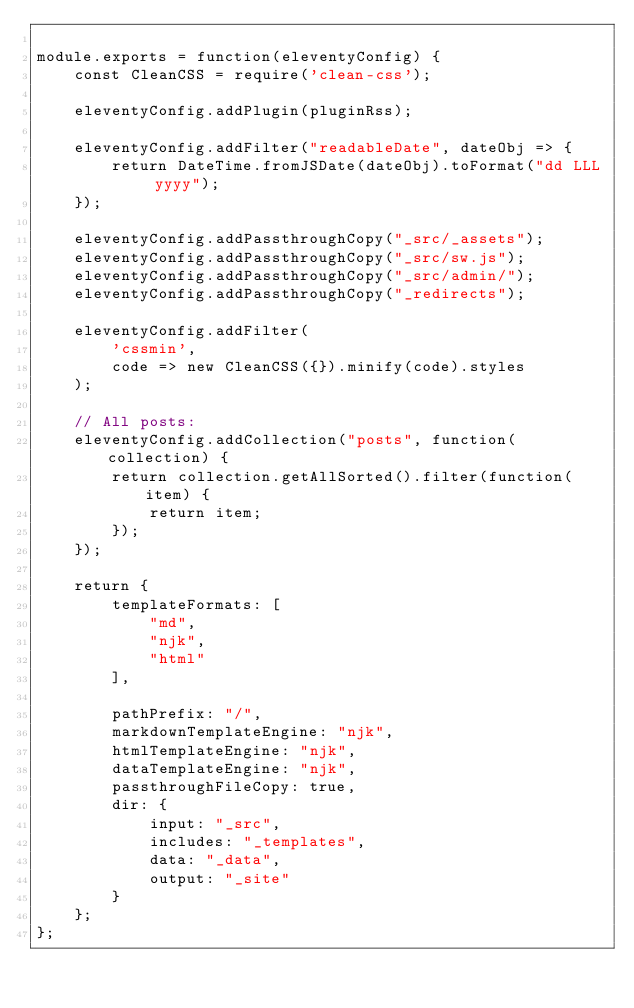Convert code to text. <code><loc_0><loc_0><loc_500><loc_500><_JavaScript_>
module.exports = function(eleventyConfig) {
	const CleanCSS = require('clean-css');

	eleventyConfig.addPlugin(pluginRss);

	eleventyConfig.addFilter("readableDate", dateObj => {
		return DateTime.fromJSDate(dateObj).toFormat("dd LLL yyyy");
	});

	eleventyConfig.addPassthroughCopy("_src/_assets");
	eleventyConfig.addPassthroughCopy("_src/sw.js");
	eleventyConfig.addPassthroughCopy("_src/admin/");
	eleventyConfig.addPassthroughCopy("_redirects");

	eleventyConfig.addFilter(
		'cssmin',
		code => new CleanCSS({}).minify(code).styles
	);

	// All posts:
	eleventyConfig.addCollection("posts", function(collection) {
		return collection.getAllSorted().filter(function(item) {
			return item;
		});
	});

	return {
		templateFormats: [
			"md",
			"njk",
			"html"
		],

		pathPrefix: "/",
		markdownTemplateEngine: "njk",
		htmlTemplateEngine: "njk",
		dataTemplateEngine: "njk",
		passthroughFileCopy: true,
		dir: {
			input: "_src",
			includes: "_templates",
			data: "_data",
			output: "_site"
		}
	};
};
</code> 